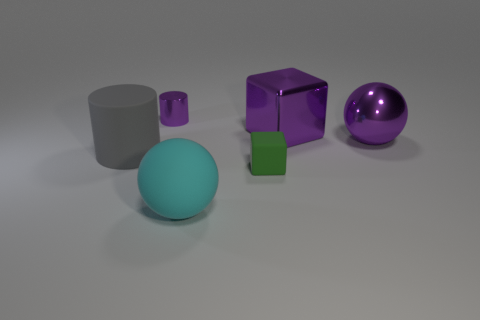Subtract all green cubes. How many cubes are left? 1 Add 3 big gray blocks. How many objects exist? 9 Subtract all spheres. How many objects are left? 4 Subtract 1 purple cubes. How many objects are left? 5 Subtract 1 cubes. How many cubes are left? 1 Subtract all gray blocks. Subtract all gray cylinders. How many blocks are left? 2 Subtract all small cylinders. Subtract all big spheres. How many objects are left? 3 Add 3 big cyan matte objects. How many big cyan matte objects are left? 4 Add 2 large gray matte cylinders. How many large gray matte cylinders exist? 3 